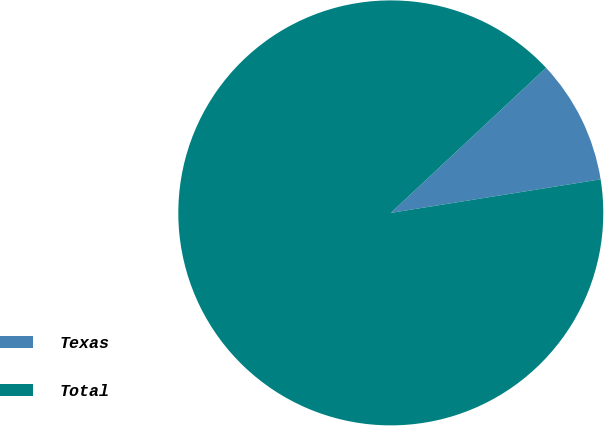Convert chart to OTSL. <chart><loc_0><loc_0><loc_500><loc_500><pie_chart><fcel>Texas<fcel>Total<nl><fcel>9.44%<fcel>90.56%<nl></chart> 